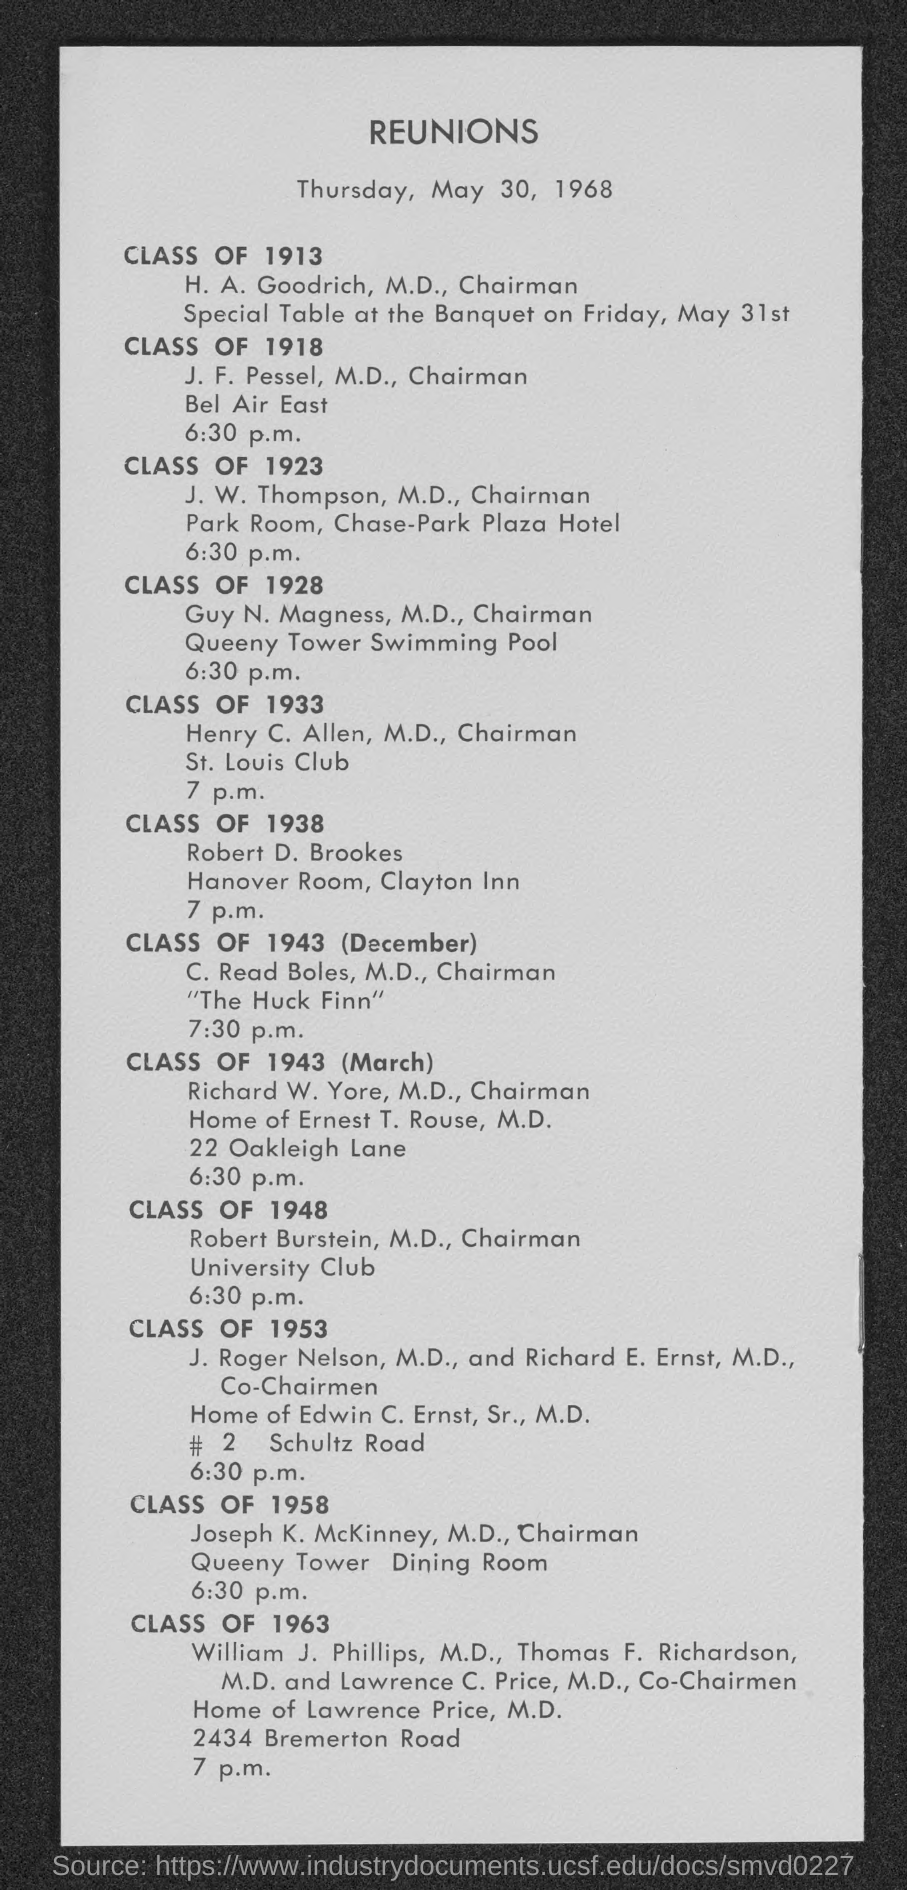When was the reunions organized?
Your answer should be very brief. Thursday, May 30, 1968. What time the reunion of the Class of 1923 was scheduled?
Offer a very short reply. 6:30 p.m. In which place, the reunion of the Class of 1933 was organized?
Your answer should be very brief. St. Louis Club. Who is the chairman for the reunion organized for the Class of 1928?
Your response must be concise. Guy N. Magness, M.D. What time the reunion of the Class of 1953 was scheduled?
Keep it short and to the point. 6.30 p.m. In which place, the reunion of the Class of 1958 was organized?
Provide a succinct answer. Queeny Tower Dining Room. 